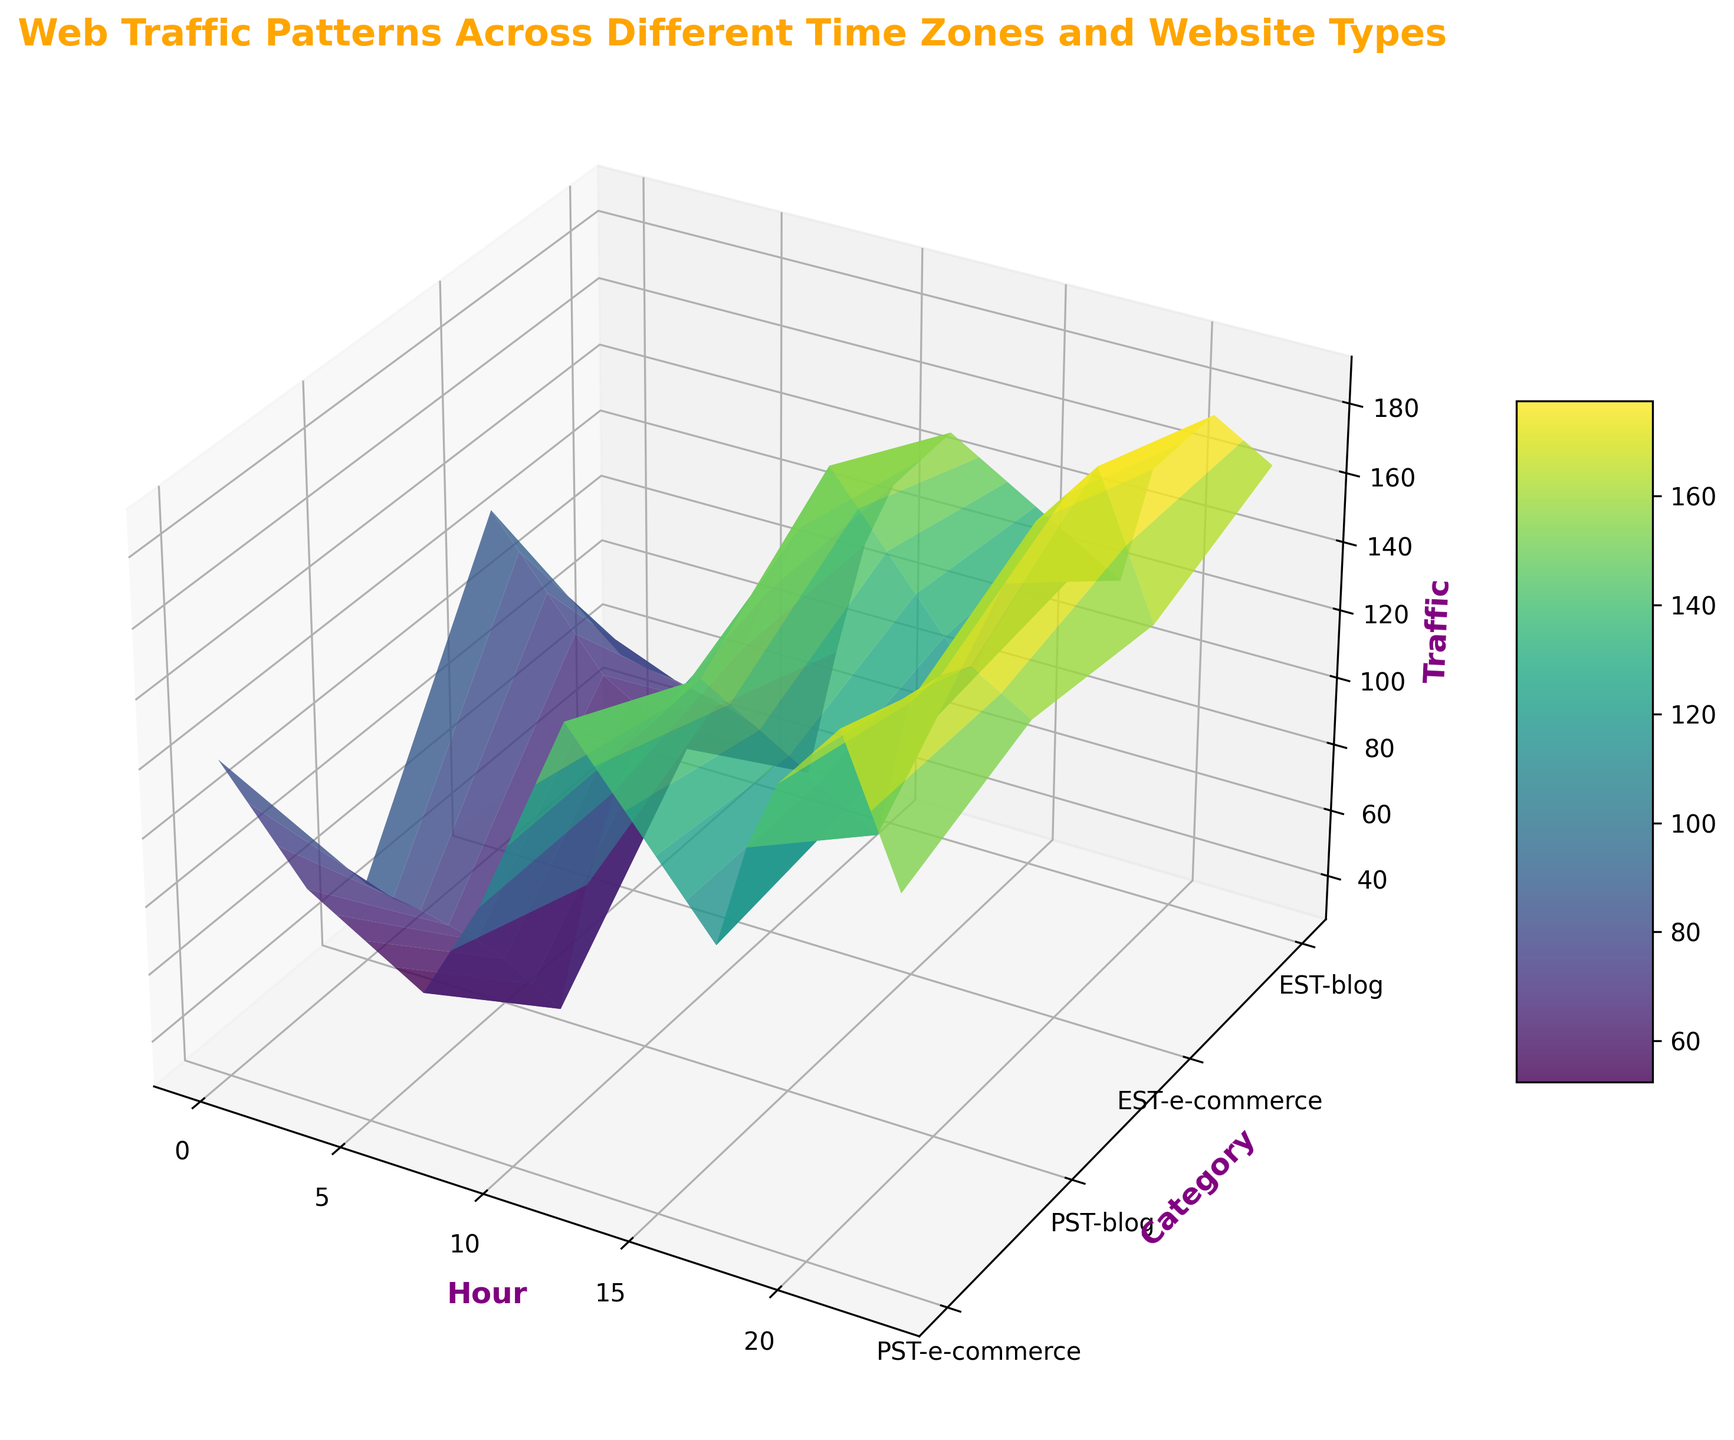What is the time zone and website type combination with the highest peak traffic? To find the highest peak traffic, observe the tallest point on the surface plot and identify its corresponding time zone and website type from the y-axis labels.
Answer: EST-e-commerce At what hour does the PST e-commerce website traffic first reach 160? Look along the curve for PST-e-commerce on the surface plot and identify the hour corresponding to the first z-axis value of 160.
Answer: 12 Which time zone has higher nighttime traffic (after 18:00) for blogs, PST or EST? Compare the height of the surface for PST-blog and EST-blog from hour 18 onwards and determine which one is higher.
Answer: EST During which hour range does e-commerce traffic in EST consistently stay above 140? Observe the e-commerce curve for EST and note the continuous hour range where the values are at least 140.
Answer: 10 to 23 At which hour does EST e-commerce website traffic surpass PST e-commerce website traffic for the first time? Compare the traffic values hour by hour starting from 0 till EST e-commerce surpasses PST e-commerce.
Answer: 0 Which has a steeper increase in traffic from 17:00 to 21:00, PST blog or PST e-commerce? Look at the slope of the curves for PST blog and PST e-commerce between 17:00 and 21:00 hours and determine which one has a greater change in height.
Answer: PST blog Which has more traffic at noon, PST blogs or EST blogs? Observe the height of the traffic at hour 12 for both PST blog and EST blog and compare them.
Answer: EST blogs 